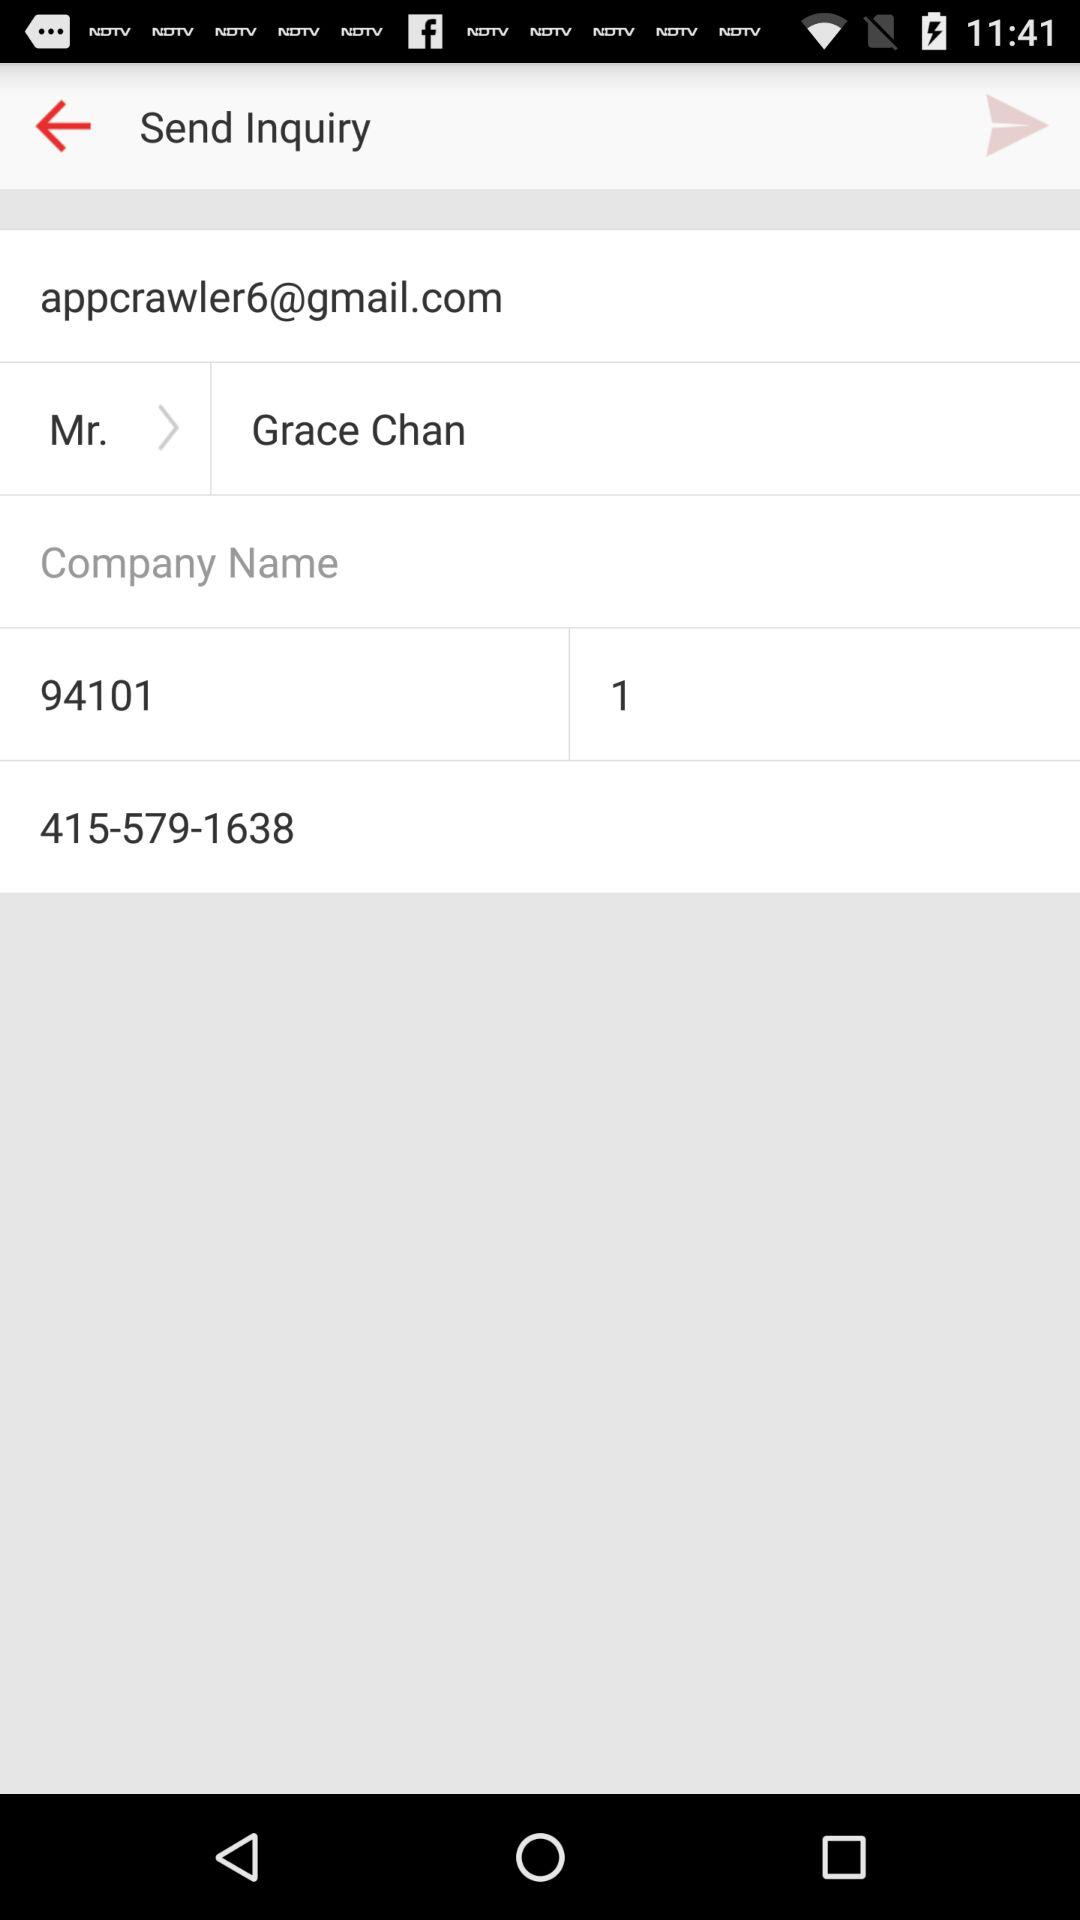What is the email address? The email address is appcrawler6@gmail.com. 